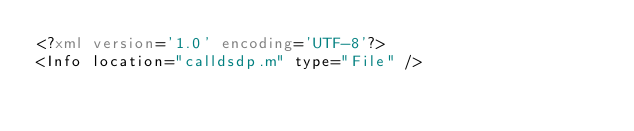Convert code to text. <code><loc_0><loc_0><loc_500><loc_500><_XML_><?xml version='1.0' encoding='UTF-8'?>
<Info location="calldsdp.m" type="File" /></code> 